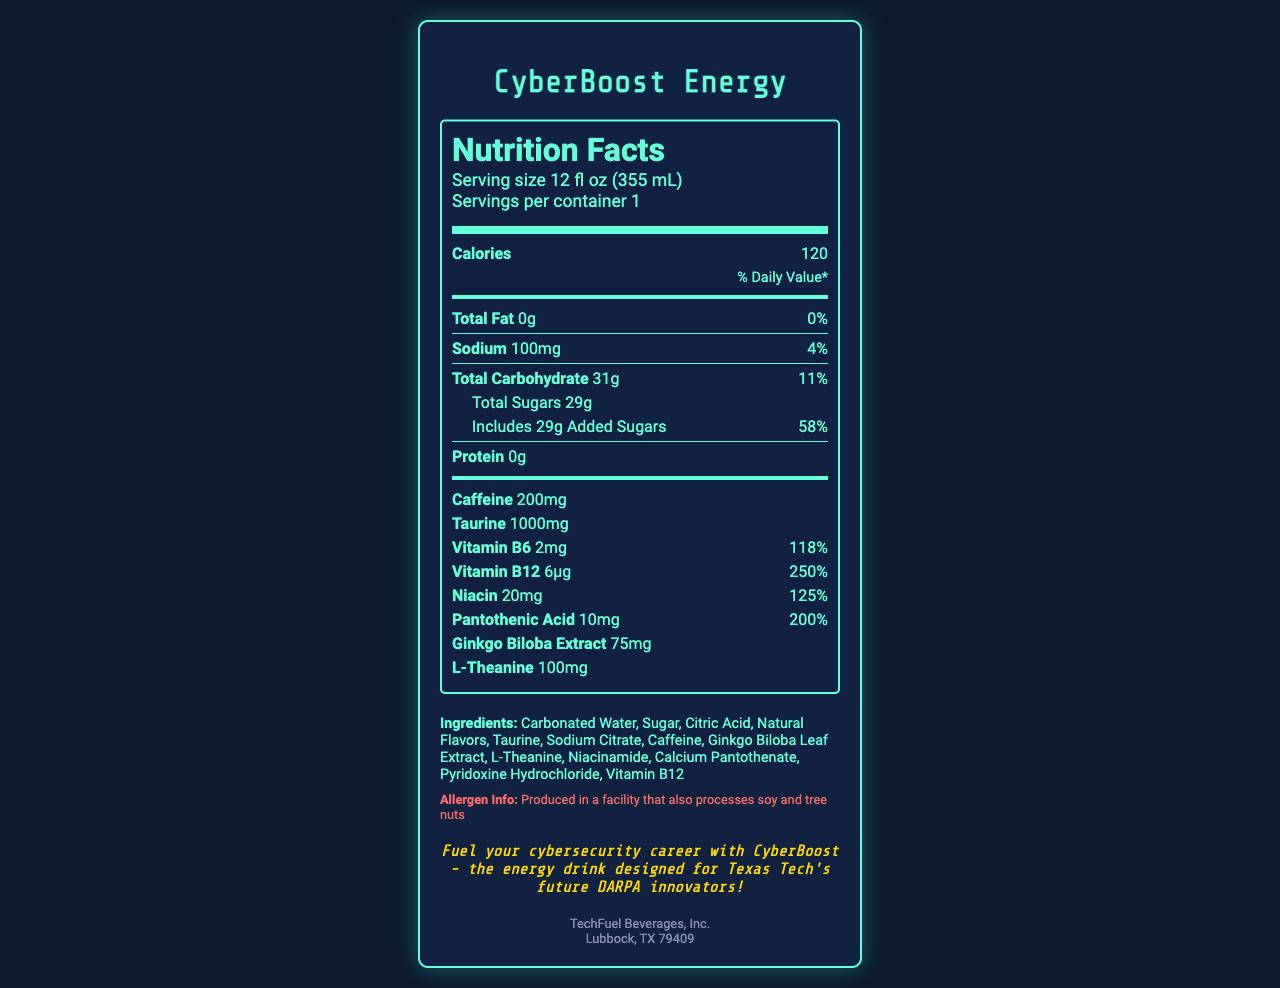what is the serving size for CyberBoost Energy? The serving size is listed clearly on the document as "Serving size 12 fl oz (355 mL)".
Answer: 12 fl oz (355 mL) how many calories are in one serving of CyberBoost Energy? The document states "Calories 120" under the nutrition information.
Answer: 120 how much total fat does CyberBoost Energy contain per serving? The line "Total Fat 0g" indicates that there is no total fat per serving.
Answer: 0g what is the daily value percentage of sodium? The sodium section mentions "Sodium 100mg" and "4%" indicating the daily value percentage.
Answer: 4% how many grams of total sugars are there in CyberBoost Energy? It states "Total Sugars 29g" under the carbohydrates section.
Answer: 29g what is the amount of caffeine per serving? The document specifies "Caffeine 200mg".
Answer: 200mg which vitamin has the highest daily value percentage in CyberBoost Energy? A. Vitamin B6 B. Vitamin B12 C. Niacin D. Pantothenic Acid The document shows "Vitamin B12 6μg 250%", "Vitamin B6 2mg 118%", "Niacin 20mg 125%", and "Pantothenic Acid 10mg 200%". Thus, Vitamin B12 has the highest daily value percentage at 250%.
Answer: B what is the main flavoring ingredient in CyberBoost Energy? A. Carbonated Water B. Sugar C. Natural Flavors D. Caffeine While "Carbonated Water" and "Sugar" are the main components, "Natural Flavors" specifically refers to the main flavoring ingredient.
Answer: C does CyberBoost Energy contain any protein? The document indicates "Protein 0g", meaning it contains no protein.
Answer: No summarize the main idea of the CyberBoost Energy Nutrition Facts label. The summary covers the essential information given about the beverage, its intended audience, and its main nutritional contents and ingredients.
Answer: CyberBoost Energy is a caffeinated beverage with ingredients designed to enhance energy and focus, particularly for cybersecurity professionals. It contains no fat, moderate carbohydrates, and is rich in vitamins B6, B12, niacin, and pantothenic acid. Caffeine, taurine, ginkgo biloba extract, and L-theanine are key ingredient highlights. The product includes significant amounts of added sugars and sodium, and it is manufactured in a facility handling soy and tree nuts. how much taurine is there per serving of CyberBoost Energy? The nutrition label clearly lists "Taurine 1000mg".
Answer: 1000mg is the document indicating that CyberBoost Energy is suitable for individuals with soy allergies? The allergen information section states, "Produced in a facility that also processes soy and tree nuts", implying potential risks for individuals with soy allergies.
Answer: No where is the manufacturer of CyberBoost Energy located? The manufacturer section at the bottom of the document states "Lubbock, TX 79409".
Answer: Lubbock, TX 79409 how many servings are in one container of CyberBoost Energy? The document indicates "Servings per container 1".
Answer: 1 which ingredient in CyberBoost Energy provides the most immediate energy boost? Among all ingredients, caffeine is well-known for providing an immediate energy boost, as indicated by "Caffeine 200mg".
Answer: Caffeine what colors are used predominantly in the design of the CyberBoost Energy Nutrition Facts label? The description mentions the label's background color, text colors, and aesthetic design, predominantly using black (#0a192f, #112240), teal (#64ffda), and some gold highlights.
Answer: Black, teal, and gold what is the recommended daily amount of pantothenic acid? The document only provides the amount of pantothenic acid and its daily value percentage but does not state the recommended daily amount.
Answer: Not enough information 